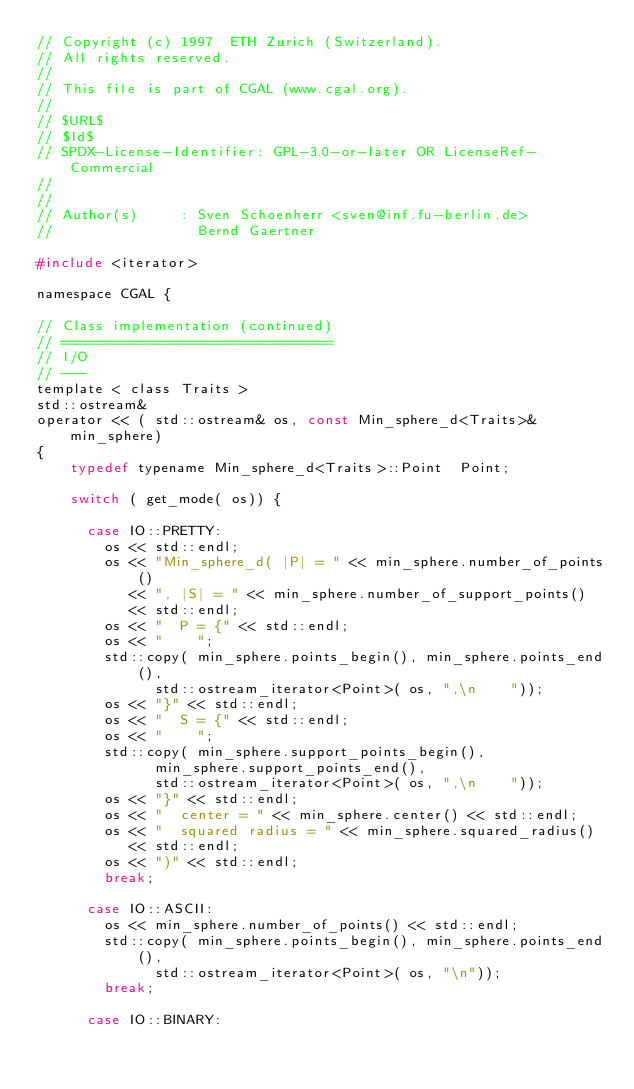<code> <loc_0><loc_0><loc_500><loc_500><_C_>// Copyright (c) 1997  ETH Zurich (Switzerland).
// All rights reserved.
//
// This file is part of CGAL (www.cgal.org).
//
// $URL$
// $Id$
// SPDX-License-Identifier: GPL-3.0-or-later OR LicenseRef-Commercial
//
//
// Author(s)     : Sven Schoenherr <sven@inf.fu-berlin.de>
//                 Bernd Gaertner

#include <iterator>

namespace CGAL {

// Class implementation (continued)
// ================================
// I/O
// ---
template < class Traits >
std::ostream&
operator << ( std::ostream& os, const Min_sphere_d<Traits>& min_sphere)
{
    typedef typename Min_sphere_d<Traits>::Point  Point;

    switch ( get_mode( os)) {

      case IO::PRETTY:
        os << std::endl;
        os << "Min_sphere_d( |P| = " << min_sphere.number_of_points()
           << ", |S| = " << min_sphere.number_of_support_points()
           << std::endl;
        os << "  P = {" << std::endl;
        os << "    ";
        std::copy( min_sphere.points_begin(), min_sphere.points_end(),
              std::ostream_iterator<Point>( os, ",\n    "));
        os << "}" << std::endl;
        os << "  S = {" << std::endl;
        os << "    ";
        std::copy( min_sphere.support_points_begin(),
              min_sphere.support_points_end(),
              std::ostream_iterator<Point>( os, ",\n    "));
        os << "}" << std::endl;
        os << "  center = " << min_sphere.center() << std::endl;
        os << "  squared radius = " << min_sphere.squared_radius()
           << std::endl;
        os << ")" << std::endl;
        break;

      case IO::ASCII:
        os << min_sphere.number_of_points() << std::endl;
        std::copy( min_sphere.points_begin(), min_sphere.points_end(),
              std::ostream_iterator<Point>( os, "\n"));
        break;

      case IO::BINARY:</code> 